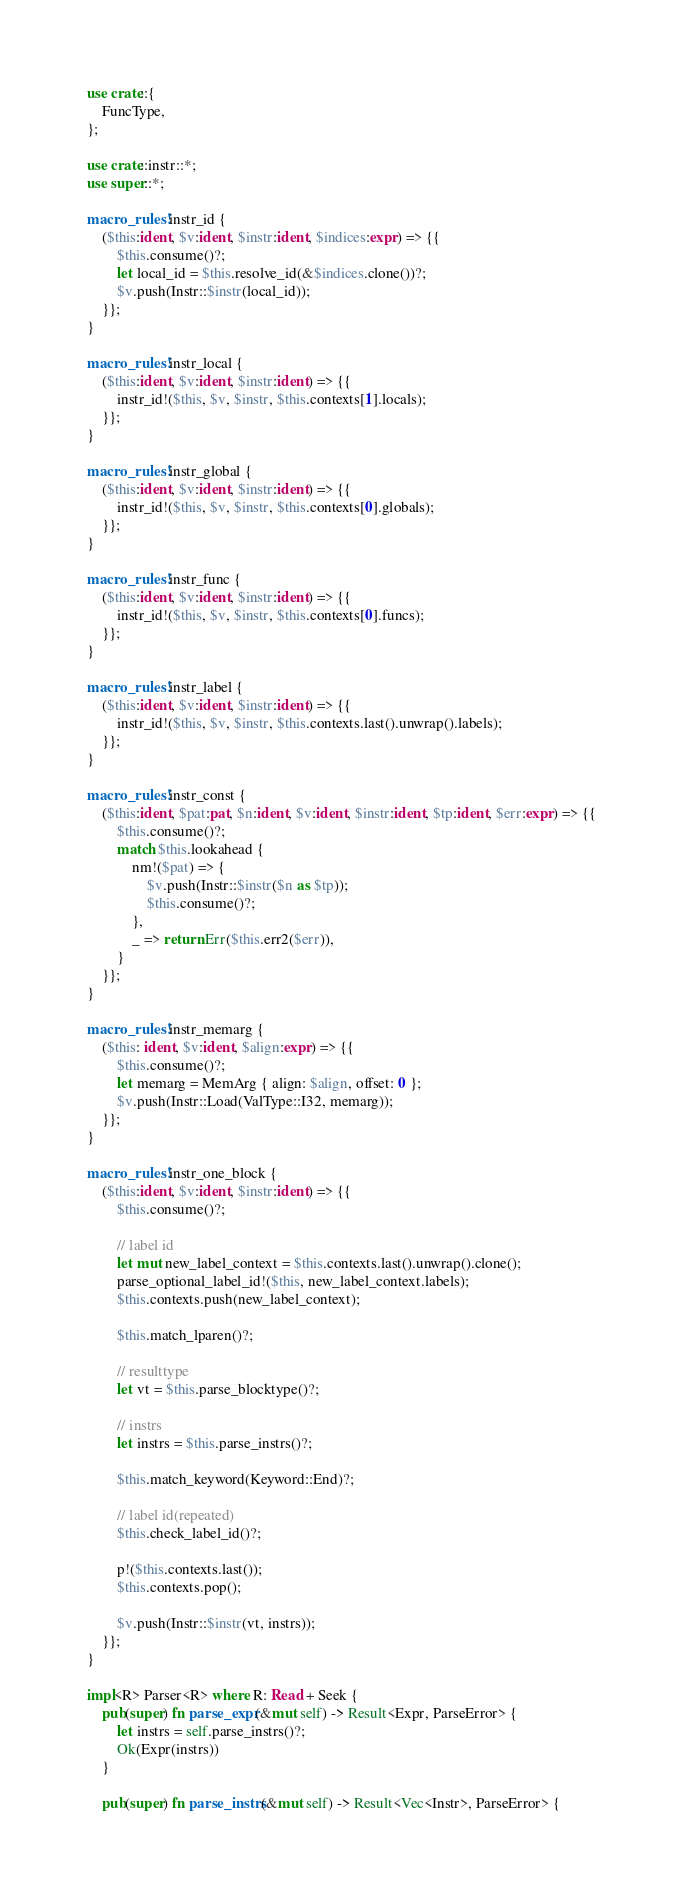<code> <loc_0><loc_0><loc_500><loc_500><_Rust_>use crate::{
    FuncType,
};

use crate::instr::*;
use super::*;

macro_rules! instr_id {
    ($this:ident, $v:ident, $instr:ident, $indices:expr) => {{
        $this.consume()?;
        let local_id = $this.resolve_id(&$indices.clone())?;
        $v.push(Instr::$instr(local_id));
    }};
}

macro_rules! instr_local {
    ($this:ident, $v:ident, $instr:ident) => {{
        instr_id!($this, $v, $instr, $this.contexts[1].locals);
    }};
}

macro_rules! instr_global {
    ($this:ident, $v:ident, $instr:ident) => {{
        instr_id!($this, $v, $instr, $this.contexts[0].globals);
    }};
}

macro_rules! instr_func {
    ($this:ident, $v:ident, $instr:ident) => {{
        instr_id!($this, $v, $instr, $this.contexts[0].funcs);
    }};
}

macro_rules! instr_label {
    ($this:ident, $v:ident, $instr:ident) => {{
        instr_id!($this, $v, $instr, $this.contexts.last().unwrap().labels);
    }};
}

macro_rules! instr_const {
    ($this:ident, $pat:pat, $n:ident, $v:ident, $instr:ident, $tp:ident, $err:expr) => {{
        $this.consume()?;
        match $this.lookahead {
            nm!($pat) => {
                $v.push(Instr::$instr($n as $tp));
                $this.consume()?;
            },
            _ => return Err($this.err2($err)),
        }
    }};
}

macro_rules! instr_memarg {
    ($this: ident, $v:ident, $align:expr) => {{
        $this.consume()?;
        let memarg = MemArg { align: $align, offset: 0 };
        $v.push(Instr::Load(ValType::I32, memarg));
    }};
}

macro_rules! instr_one_block {
    ($this:ident, $v:ident, $instr:ident) => {{
        $this.consume()?;

        // label id
        let mut new_label_context = $this.contexts.last().unwrap().clone();
        parse_optional_label_id!($this, new_label_context.labels);
        $this.contexts.push(new_label_context);

        $this.match_lparen()?;

        // resulttype
        let vt = $this.parse_blocktype()?;

        // instrs
        let instrs = $this.parse_instrs()?;

        $this.match_keyword(Keyword::End)?;

        // label id(repeated)
        $this.check_label_id()?;

        p!($this.contexts.last());
        $this.contexts.pop();

        $v.push(Instr::$instr(vt, instrs));
    }};
}

impl<R> Parser<R> where R: Read + Seek {
    pub(super) fn parse_expr(&mut self) -> Result<Expr, ParseError> {
        let instrs = self.parse_instrs()?;
        Ok(Expr(instrs))
    }

    pub(super) fn parse_instrs(&mut self) -> Result<Vec<Instr>, ParseError> {</code> 